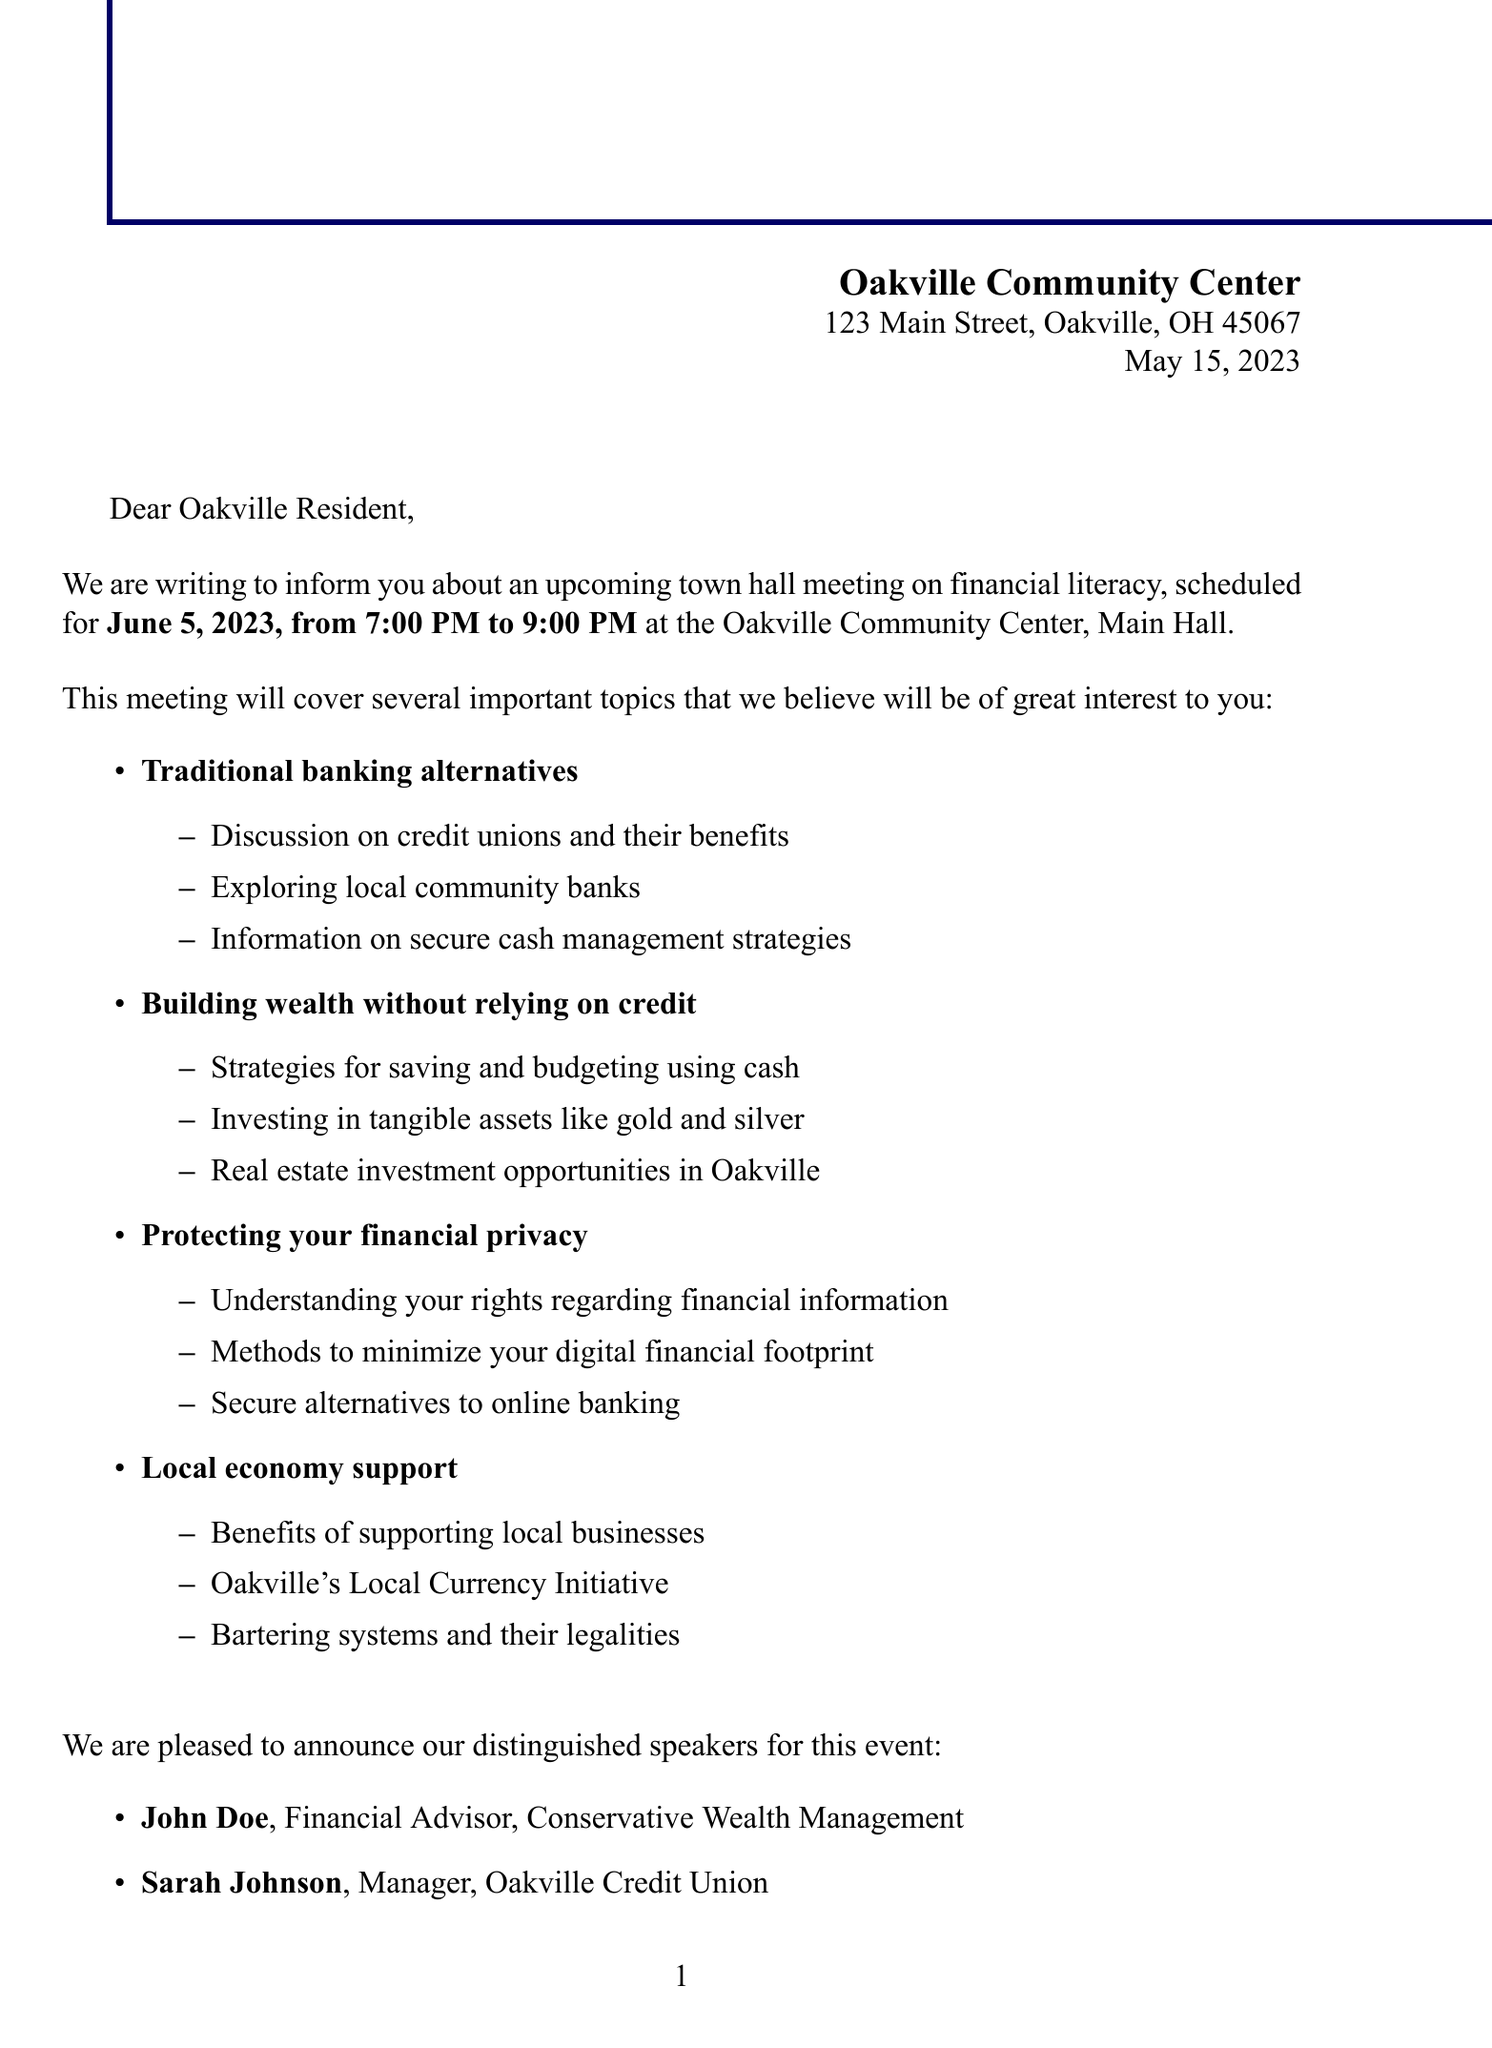What is the date of the meeting? The date of the meeting is mentioned explicitly in the document as June 5, 2023.
Answer: June 5, 2023 Who is the contact person for the event? The document specifies Emily Wilson as the contact person for any questions.
Answer: Emily Wilson What time does the meeting start? The meeting start time is listed in the document as 7:00 PM.
Answer: 7:00 PM What is one topic that will be discussed at the meeting? The document includes multiple topics, one of which is "Building wealth without relying on credit".
Answer: Building wealth without relying on credit Who is speaking about protecting financial information? The document names Michael Brown as the speaker on this topic.
Answer: Michael Brown What type of event is mentioned in the document? The event is specified as a town hall meeting focused on financial literacy.
Answer: Town hall meeting Is parking available at the community center? The document confirms that free parking is available in the community center lot.
Answer: Free parking Will refreshments be provided? The document states that light refreshments will be provided during the event.
Answer: Light refreshments What is one alternative to traditional banks mentioned in the meeting topics? The document mentions credit unions as an alternative to traditional banks.
Answer: Credit unions 